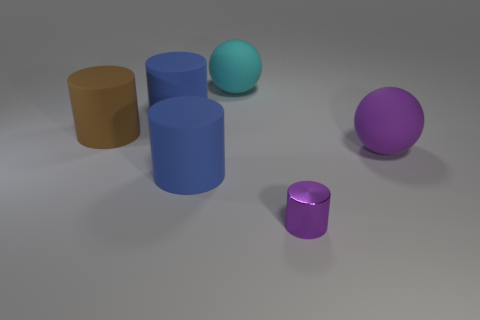Add 2 matte balls. How many objects exist? 8 Subtract all cylinders. How many objects are left? 2 Subtract 0 yellow spheres. How many objects are left? 6 Subtract all tiny cyan metallic balls. Subtract all small purple metal cylinders. How many objects are left? 5 Add 2 cyan matte balls. How many cyan matte balls are left? 3 Add 5 big matte balls. How many big matte balls exist? 7 